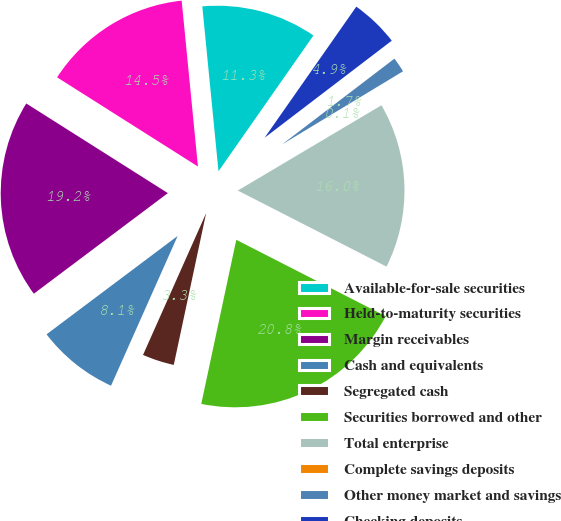<chart> <loc_0><loc_0><loc_500><loc_500><pie_chart><fcel>Available-for-sale securities<fcel>Held-to-maturity securities<fcel>Margin receivables<fcel>Cash and equivalents<fcel>Segregated cash<fcel>Securities borrowed and other<fcel>Total enterprise<fcel>Complete savings deposits<fcel>Other money market and savings<fcel>Checking deposits<nl><fcel>11.27%<fcel>14.46%<fcel>19.23%<fcel>8.09%<fcel>3.32%<fcel>20.82%<fcel>16.05%<fcel>0.13%<fcel>1.72%<fcel>4.91%<nl></chart> 